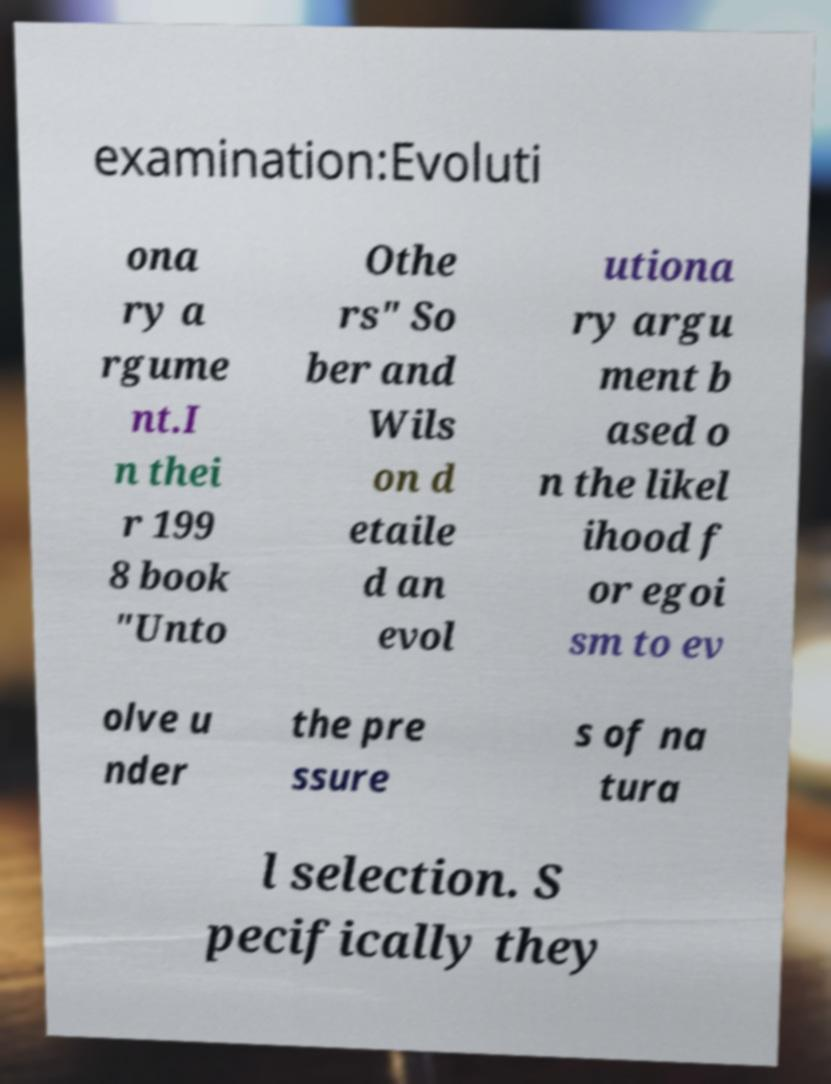Can you accurately transcribe the text from the provided image for me? examination:Evoluti ona ry a rgume nt.I n thei r 199 8 book "Unto Othe rs" So ber and Wils on d etaile d an evol utiona ry argu ment b ased o n the likel ihood f or egoi sm to ev olve u nder the pre ssure s of na tura l selection. S pecifically they 